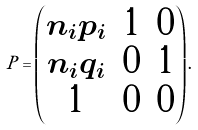Convert formula to latex. <formula><loc_0><loc_0><loc_500><loc_500>P = \begin{pmatrix} n _ { i } p _ { i } & 1 & 0 \\ n _ { i } q _ { i } & 0 & 1 \\ 1 & 0 & 0 \end{pmatrix} .</formula> 